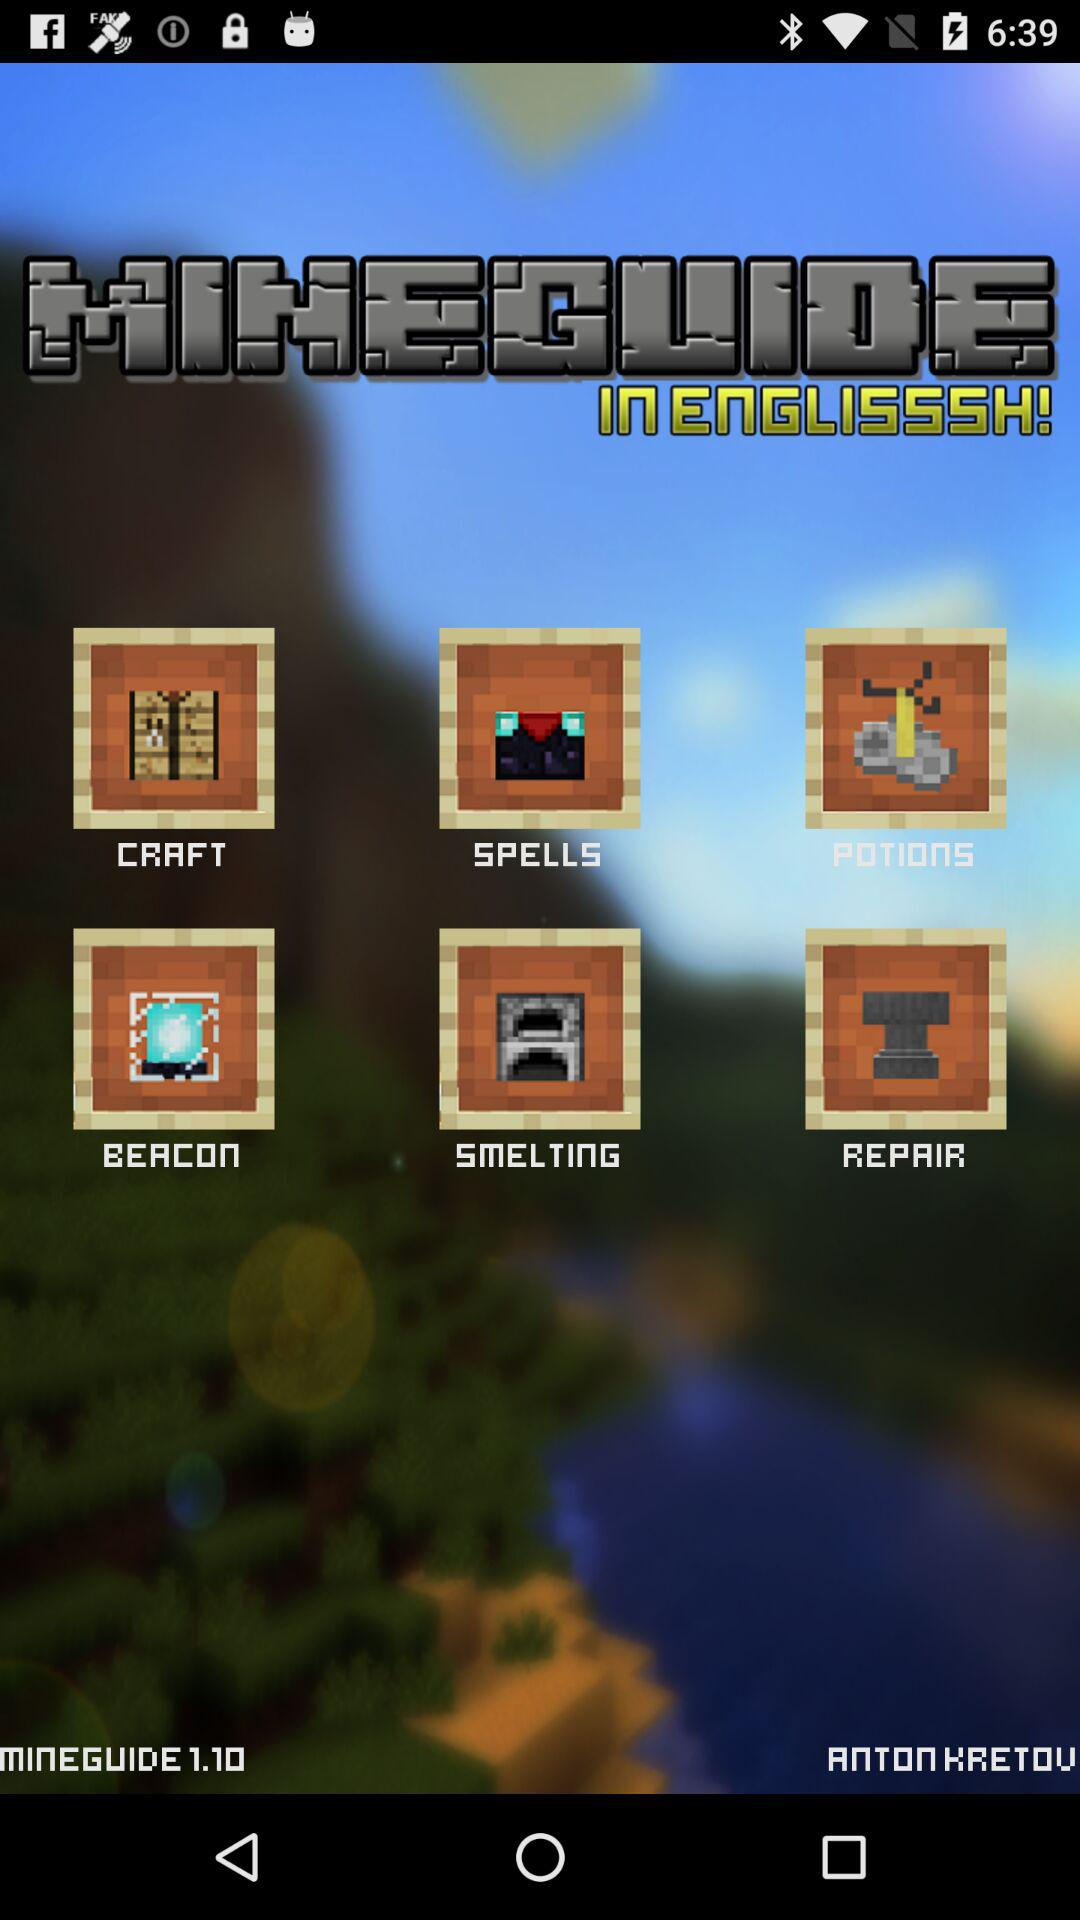When was "MINEGUIDE" updated to version 1.10?
When the provided information is insufficient, respond with <no answer>. <no answer> 